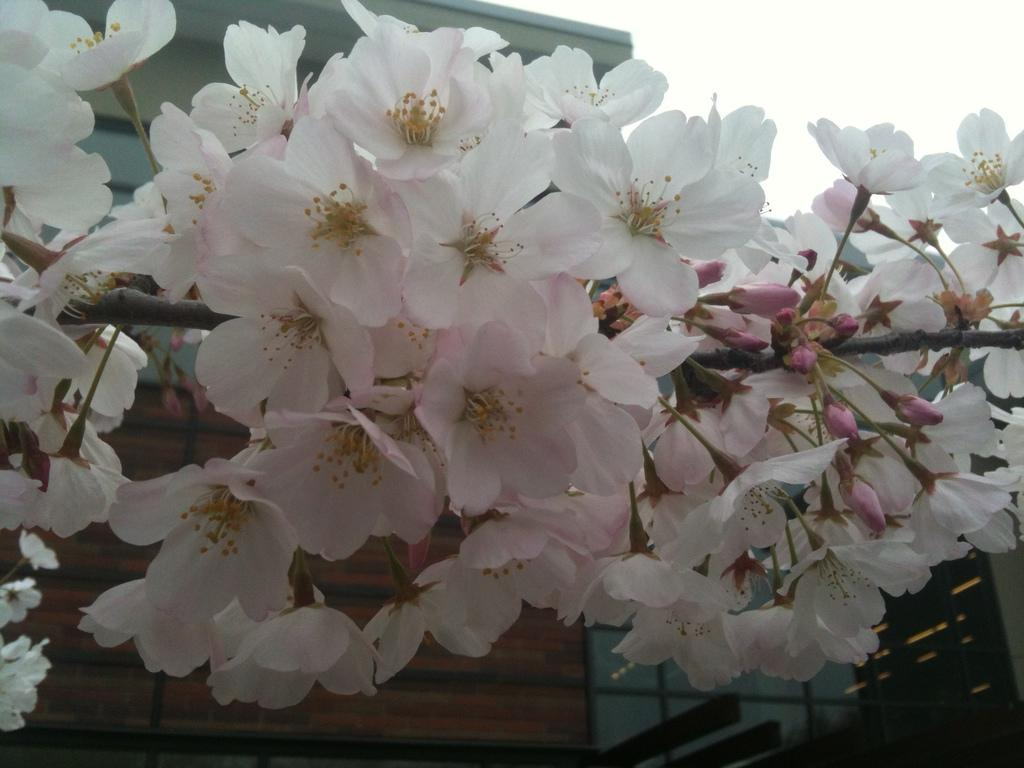What colors are the flowers in the image? The flowers in the image are in pink and white colors. What is the color of the building in the image? The building in the image is in a cream color. What color is the sky in the image? The sky is white in the image. How many apples can be seen hanging from the branches in the image? There are no apples or branches present in the image. What type of snakes are slithering around the building in the image? There are no snakes present in the image; it features flowers, a building, and a white sky. 